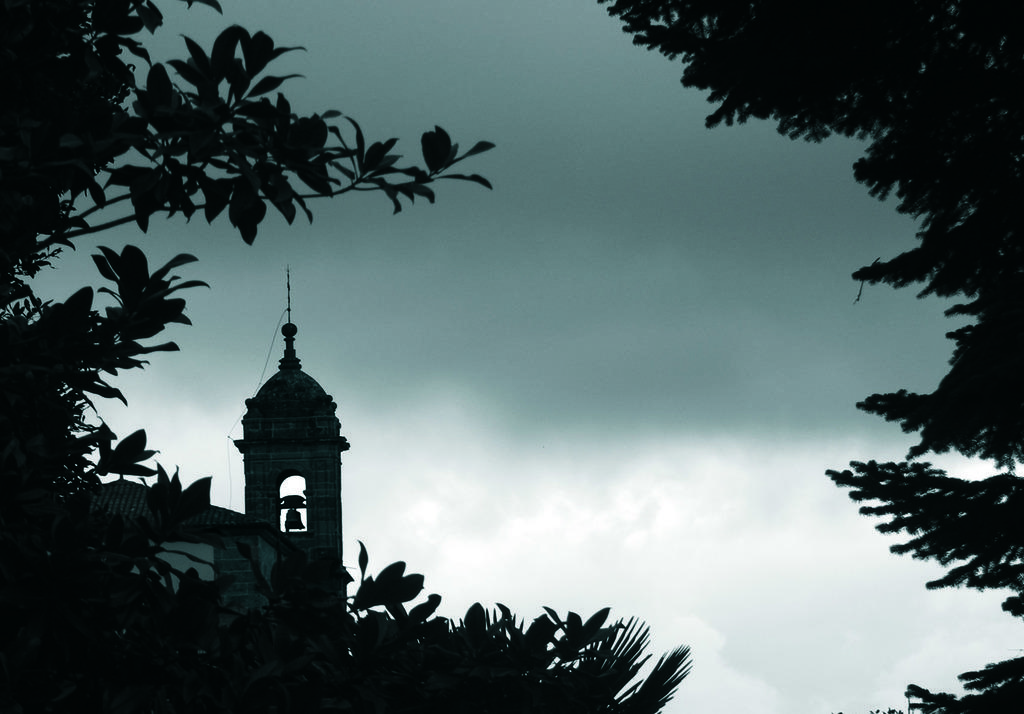What type of structure is present in the image? There is a building in the image. What can be seen on the left side of the image? There are trees on the left side of the image. What can be seen on the right side of the image? There are trees on the right side of the image. What is visible in the background of the image? The sky is visible in the background of the image. What type of knot is being tied by the person in the bedroom in the image? There is no person or bedroom present in the image, and therefore no knot-tying activity can be observed. 